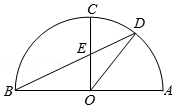First perform reasoning, then finally select the question from the choices in the following format: Answer: xxx.
Question: As shown in the figure, in semicircle O with AB as the diameter, AC=BC. Point D is a point on AC. Connect OC. BD intersects at point E. Connect OD. If angle DEC = 65°, then the degree of angle DOC is ().
Choices:
A: 25°
B: 32.5°
C: 35°
D: 40° since AC=BC, therefore, OC is perpendicular to AB, therefore, angle BOC = angle AOC = 90 degrees. since angle OEB = angle DEC = 65 degrees, therefore, angle ABD = 90 degrees - angle OEB = 25 degrees. therefore, angle AOD = 2angle ABD = 50 degrees, therefore, angle DOC = 90 degrees - angle AOD = 40 degrees. Therefore, the answer is: D.
Answer:D 